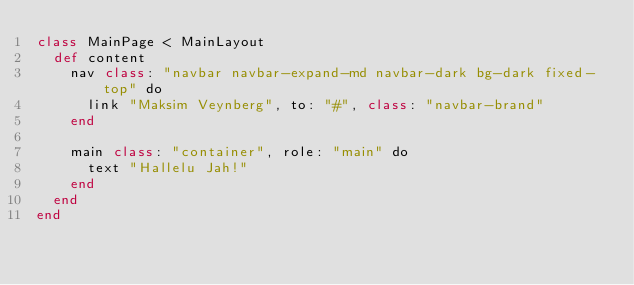<code> <loc_0><loc_0><loc_500><loc_500><_Crystal_>class MainPage < MainLayout
  def content
    nav class: "navbar navbar-expand-md navbar-dark bg-dark fixed-top" do
      link "Maksim Veynberg", to: "#", class: "navbar-brand"
    end

    main class: "container", role: "main" do
      text "Hallelu Jah!"
    end
  end
end
</code> 